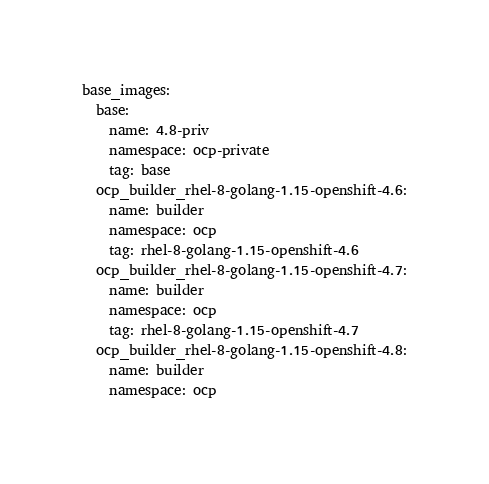<code> <loc_0><loc_0><loc_500><loc_500><_YAML_>base_images:
  base:
    name: 4.8-priv
    namespace: ocp-private
    tag: base
  ocp_builder_rhel-8-golang-1.15-openshift-4.6:
    name: builder
    namespace: ocp
    tag: rhel-8-golang-1.15-openshift-4.6
  ocp_builder_rhel-8-golang-1.15-openshift-4.7:
    name: builder
    namespace: ocp
    tag: rhel-8-golang-1.15-openshift-4.7
  ocp_builder_rhel-8-golang-1.15-openshift-4.8:
    name: builder
    namespace: ocp</code> 